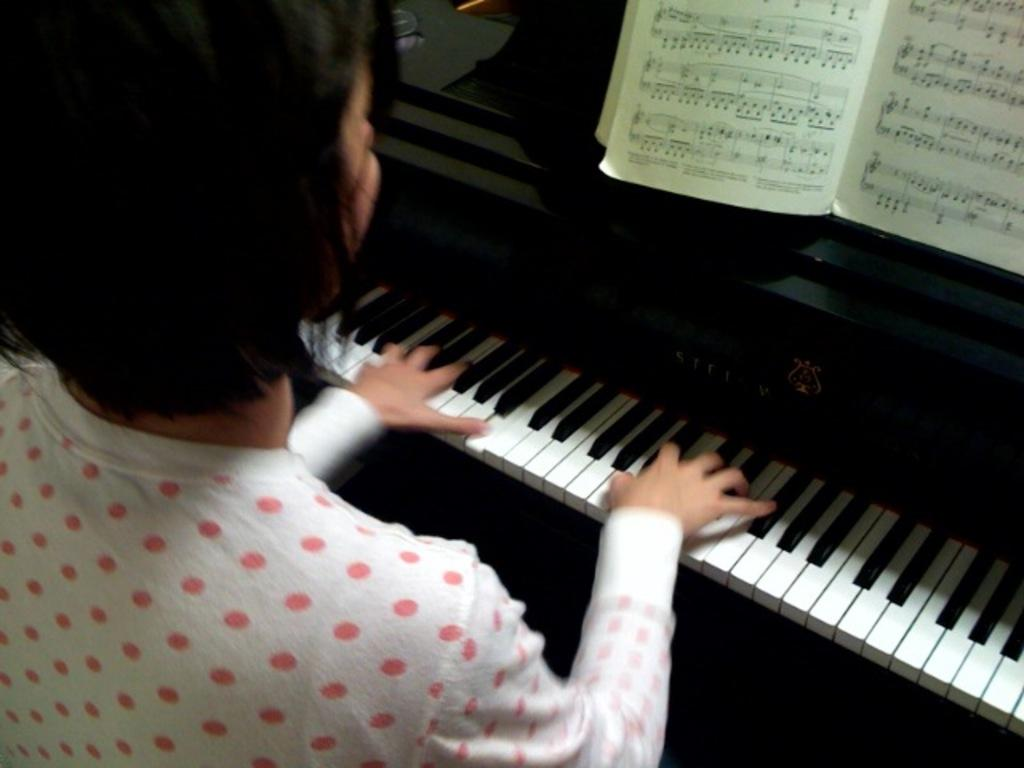What is the person in the image doing? The person is playing a piano. Can you describe any other objects in the image? Yes, there is a book in the image. Are there any caves visible in the image? No, there are no caves present in the image. How many spiders can be seen crawling on the book in the image? There are no spiders visible in the image. 